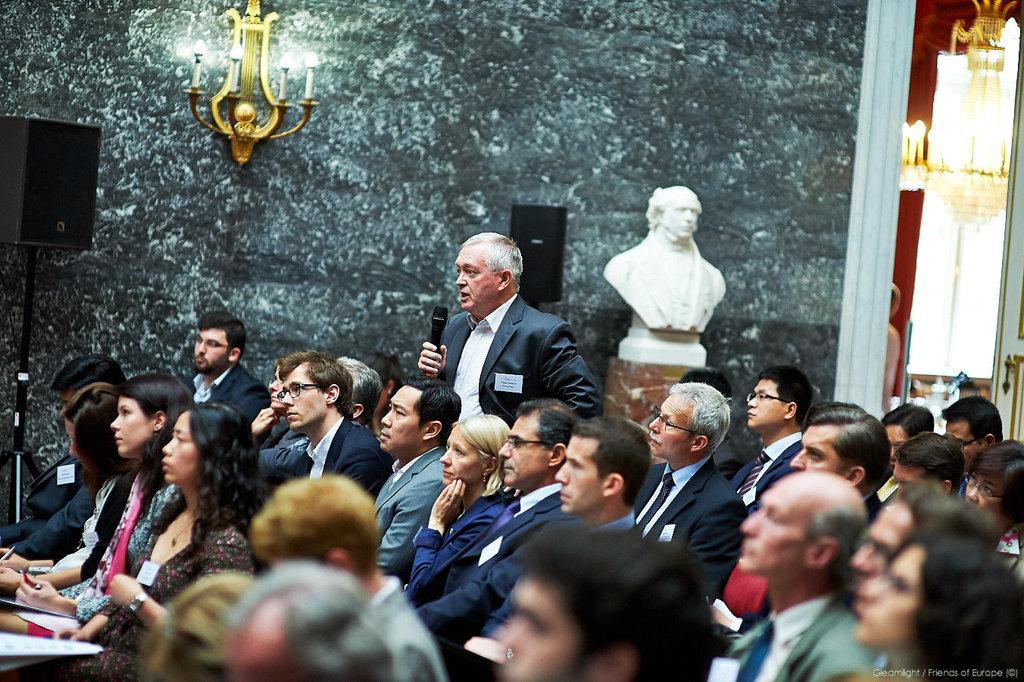What are the people in the image doing? The people in the image are sitting, while one person is standing and holding a mic in their hand. What can be seen in the background of the image? There is a sculpture, lights, and stands in the background of the image. How many women are present in the image? The provided facts do not mention the gender of the people in the image, so it cannot be determined if there are any women present. 